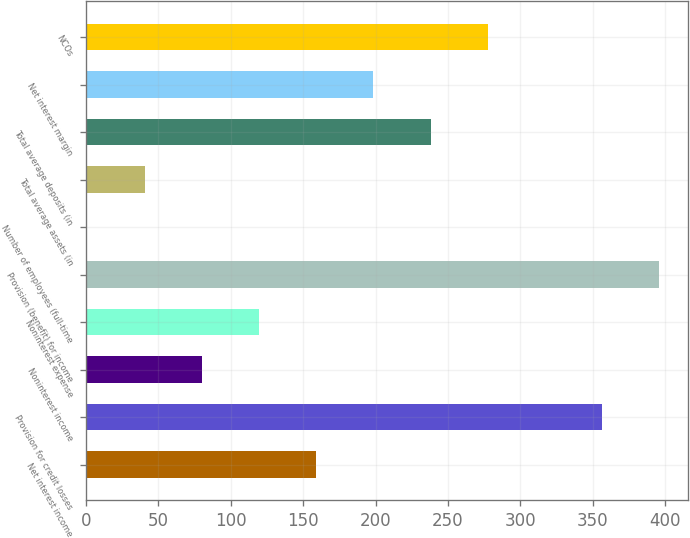Convert chart. <chart><loc_0><loc_0><loc_500><loc_500><bar_chart><fcel>Net interest income<fcel>Provision for credit losses<fcel>Noninterest income<fcel>Noninterest expense<fcel>Provision (benefit) for income<fcel>Number of employees (full-time<fcel>Total average assets (in<fcel>Total average deposits (in<fcel>Net interest margin<fcel>NCOs<nl><fcel>159<fcel>356.5<fcel>80<fcel>119.5<fcel>396<fcel>1<fcel>40.5<fcel>238<fcel>198.5<fcel>277.5<nl></chart> 